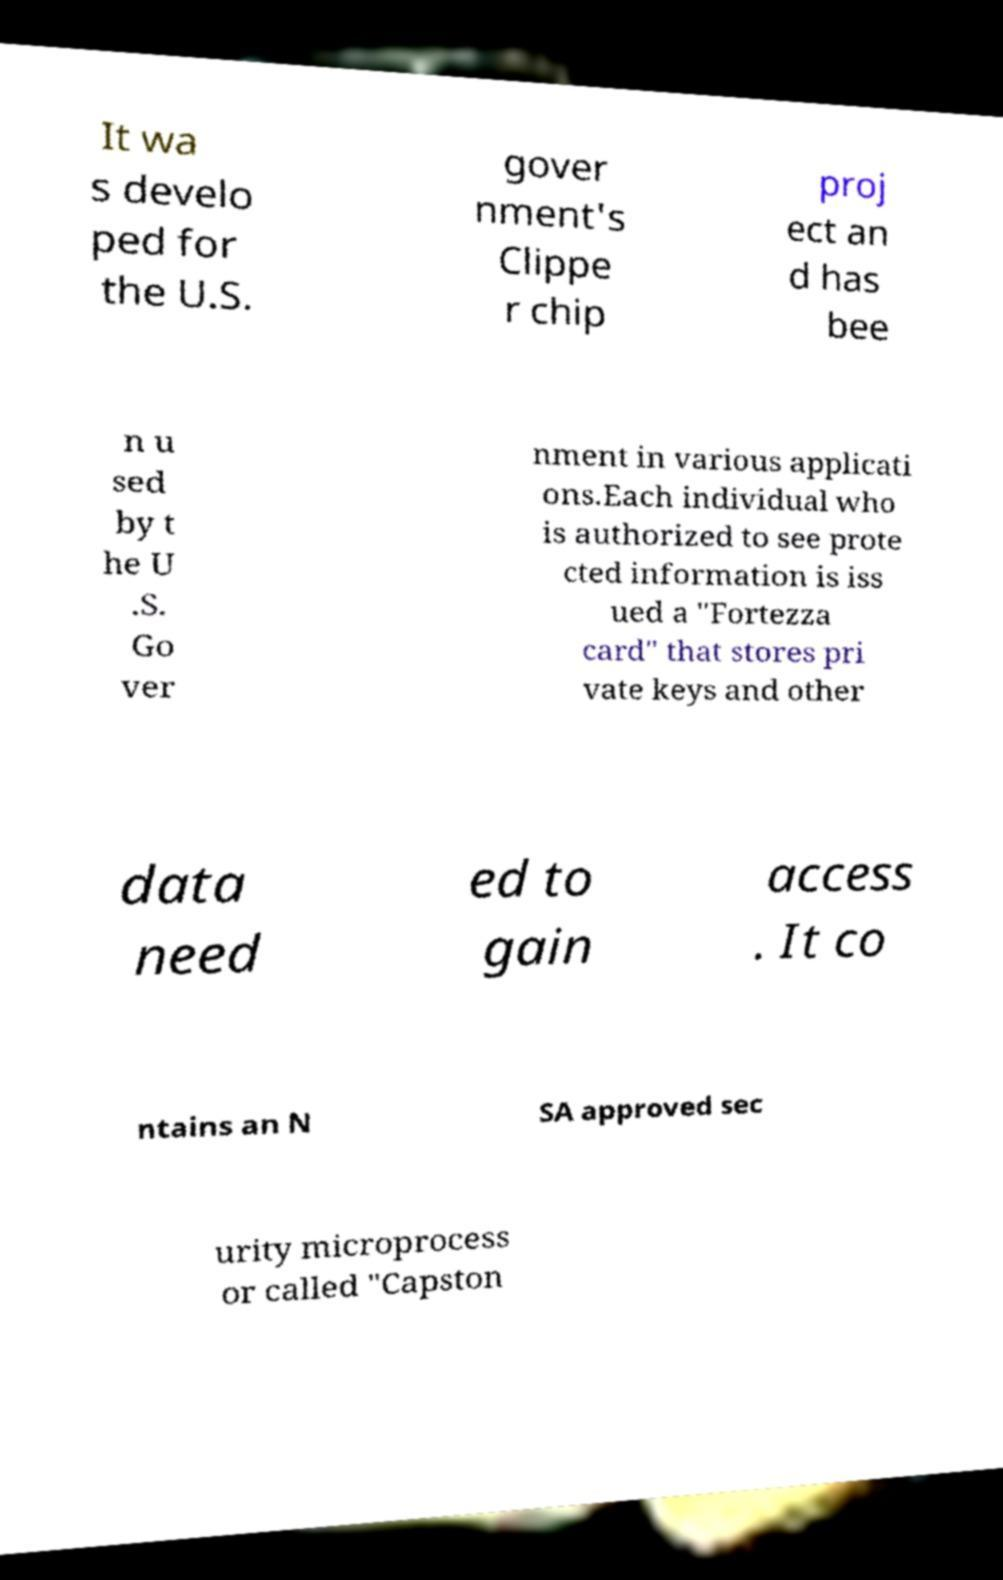I need the written content from this picture converted into text. Can you do that? It wa s develo ped for the U.S. gover nment's Clippe r chip proj ect an d has bee n u sed by t he U .S. Go ver nment in various applicati ons.Each individual who is authorized to see prote cted information is iss ued a "Fortezza card" that stores pri vate keys and other data need ed to gain access . It co ntains an N SA approved sec urity microprocess or called "Capston 